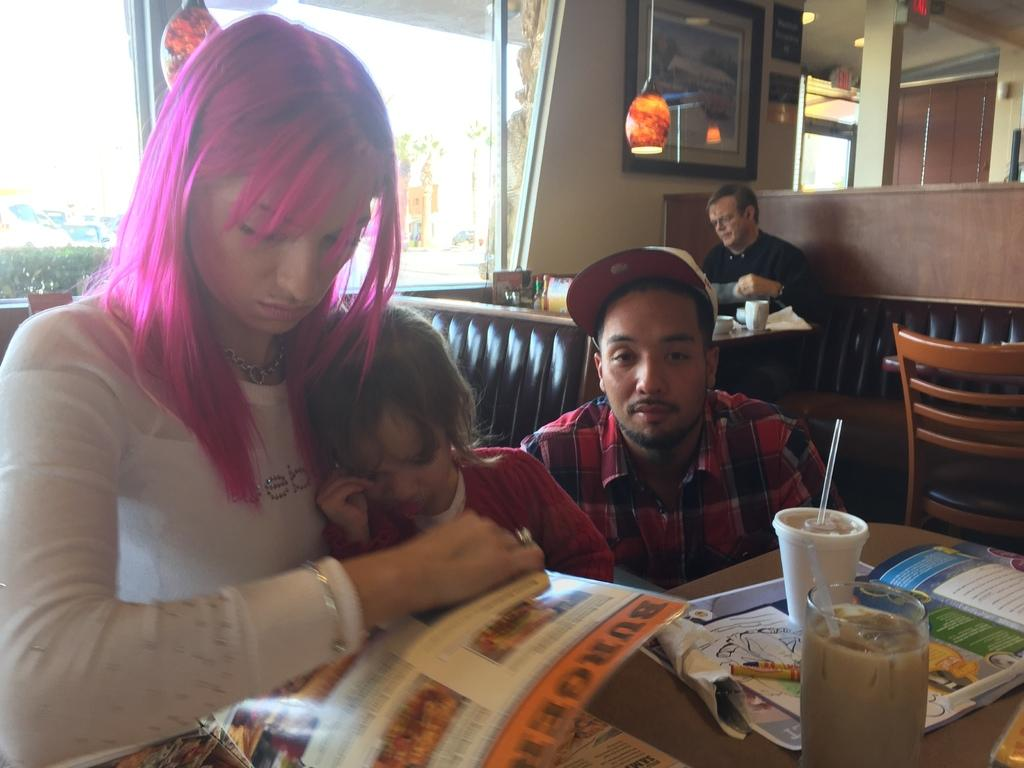What are the people in the image doing? The people in the image are sitting on chairs at a table. What objects can be seen on the table? There is a glass, a cup, and a book on the table. Can you describe the window in the image? Vehicles are visible through a window in the image. What type of yam is being used as a coaster for the glass in the image? There is no yam present in the image, and the glass is not resting on a yam. 